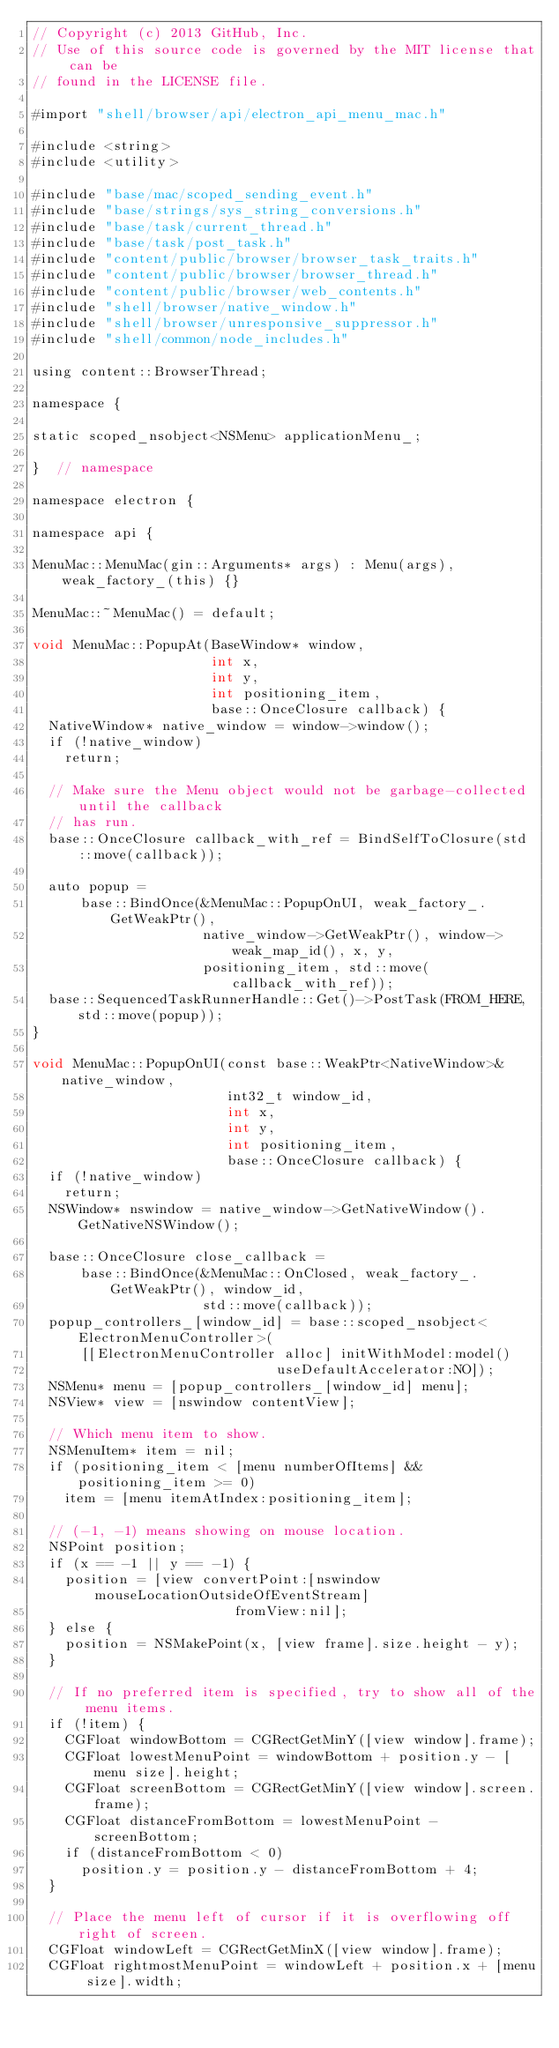Convert code to text. <code><loc_0><loc_0><loc_500><loc_500><_ObjectiveC_>// Copyright (c) 2013 GitHub, Inc.
// Use of this source code is governed by the MIT license that can be
// found in the LICENSE file.

#import "shell/browser/api/electron_api_menu_mac.h"

#include <string>
#include <utility>

#include "base/mac/scoped_sending_event.h"
#include "base/strings/sys_string_conversions.h"
#include "base/task/current_thread.h"
#include "base/task/post_task.h"
#include "content/public/browser/browser_task_traits.h"
#include "content/public/browser/browser_thread.h"
#include "content/public/browser/web_contents.h"
#include "shell/browser/native_window.h"
#include "shell/browser/unresponsive_suppressor.h"
#include "shell/common/node_includes.h"

using content::BrowserThread;

namespace {

static scoped_nsobject<NSMenu> applicationMenu_;

}  // namespace

namespace electron {

namespace api {

MenuMac::MenuMac(gin::Arguments* args) : Menu(args), weak_factory_(this) {}

MenuMac::~MenuMac() = default;

void MenuMac::PopupAt(BaseWindow* window,
                      int x,
                      int y,
                      int positioning_item,
                      base::OnceClosure callback) {
  NativeWindow* native_window = window->window();
  if (!native_window)
    return;

  // Make sure the Menu object would not be garbage-collected until the callback
  // has run.
  base::OnceClosure callback_with_ref = BindSelfToClosure(std::move(callback));

  auto popup =
      base::BindOnce(&MenuMac::PopupOnUI, weak_factory_.GetWeakPtr(),
                     native_window->GetWeakPtr(), window->weak_map_id(), x, y,
                     positioning_item, std::move(callback_with_ref));
  base::SequencedTaskRunnerHandle::Get()->PostTask(FROM_HERE, std::move(popup));
}

void MenuMac::PopupOnUI(const base::WeakPtr<NativeWindow>& native_window,
                        int32_t window_id,
                        int x,
                        int y,
                        int positioning_item,
                        base::OnceClosure callback) {
  if (!native_window)
    return;
  NSWindow* nswindow = native_window->GetNativeWindow().GetNativeNSWindow();

  base::OnceClosure close_callback =
      base::BindOnce(&MenuMac::OnClosed, weak_factory_.GetWeakPtr(), window_id,
                     std::move(callback));
  popup_controllers_[window_id] = base::scoped_nsobject<ElectronMenuController>(
      [[ElectronMenuController alloc] initWithModel:model()
                              useDefaultAccelerator:NO]);
  NSMenu* menu = [popup_controllers_[window_id] menu];
  NSView* view = [nswindow contentView];

  // Which menu item to show.
  NSMenuItem* item = nil;
  if (positioning_item < [menu numberOfItems] && positioning_item >= 0)
    item = [menu itemAtIndex:positioning_item];

  // (-1, -1) means showing on mouse location.
  NSPoint position;
  if (x == -1 || y == -1) {
    position = [view convertPoint:[nswindow mouseLocationOutsideOfEventStream]
                         fromView:nil];
  } else {
    position = NSMakePoint(x, [view frame].size.height - y);
  }

  // If no preferred item is specified, try to show all of the menu items.
  if (!item) {
    CGFloat windowBottom = CGRectGetMinY([view window].frame);
    CGFloat lowestMenuPoint = windowBottom + position.y - [menu size].height;
    CGFloat screenBottom = CGRectGetMinY([view window].screen.frame);
    CGFloat distanceFromBottom = lowestMenuPoint - screenBottom;
    if (distanceFromBottom < 0)
      position.y = position.y - distanceFromBottom + 4;
  }

  // Place the menu left of cursor if it is overflowing off right of screen.
  CGFloat windowLeft = CGRectGetMinX([view window].frame);
  CGFloat rightmostMenuPoint = windowLeft + position.x + [menu size].width;</code> 